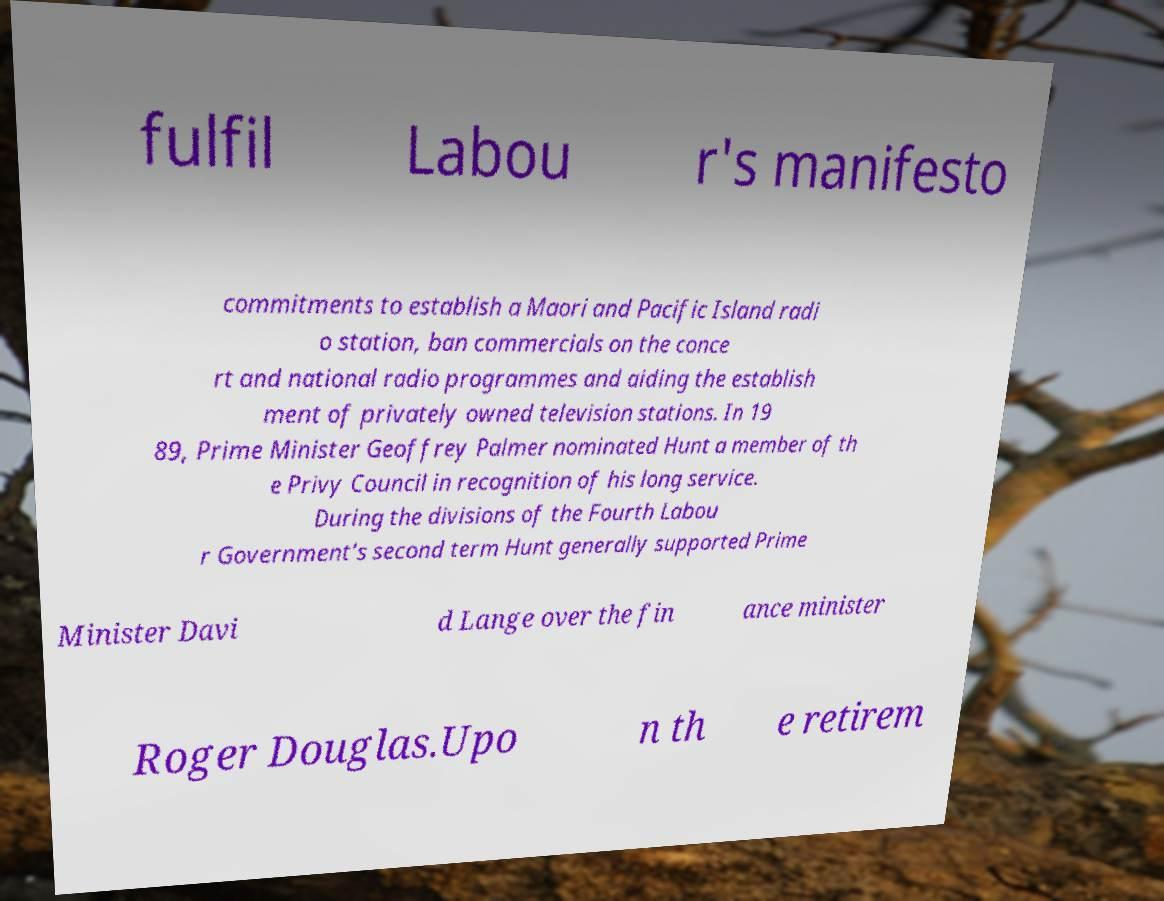Can you accurately transcribe the text from the provided image for me? fulfil Labou r's manifesto commitments to establish a Maori and Pacific Island radi o station, ban commercials on the conce rt and national radio programmes and aiding the establish ment of privately owned television stations. In 19 89, Prime Minister Geoffrey Palmer nominated Hunt a member of th e Privy Council in recognition of his long service. During the divisions of the Fourth Labou r Government's second term Hunt generally supported Prime Minister Davi d Lange over the fin ance minister Roger Douglas.Upo n th e retirem 